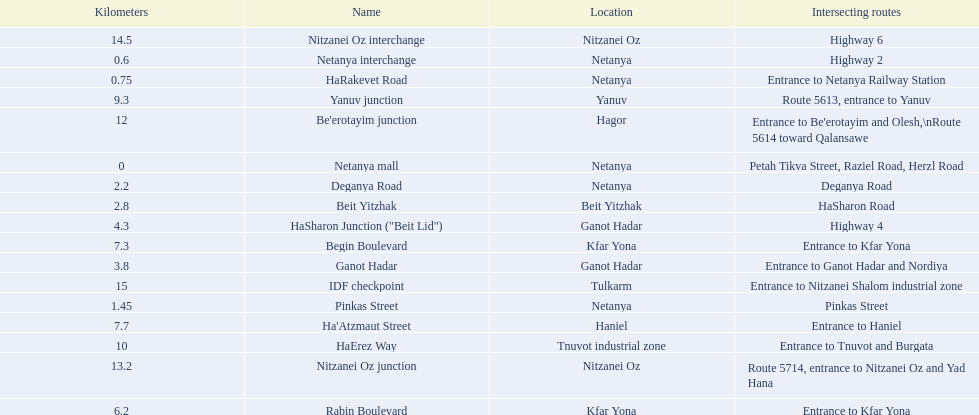How many sections intersect highway 2? 1. 